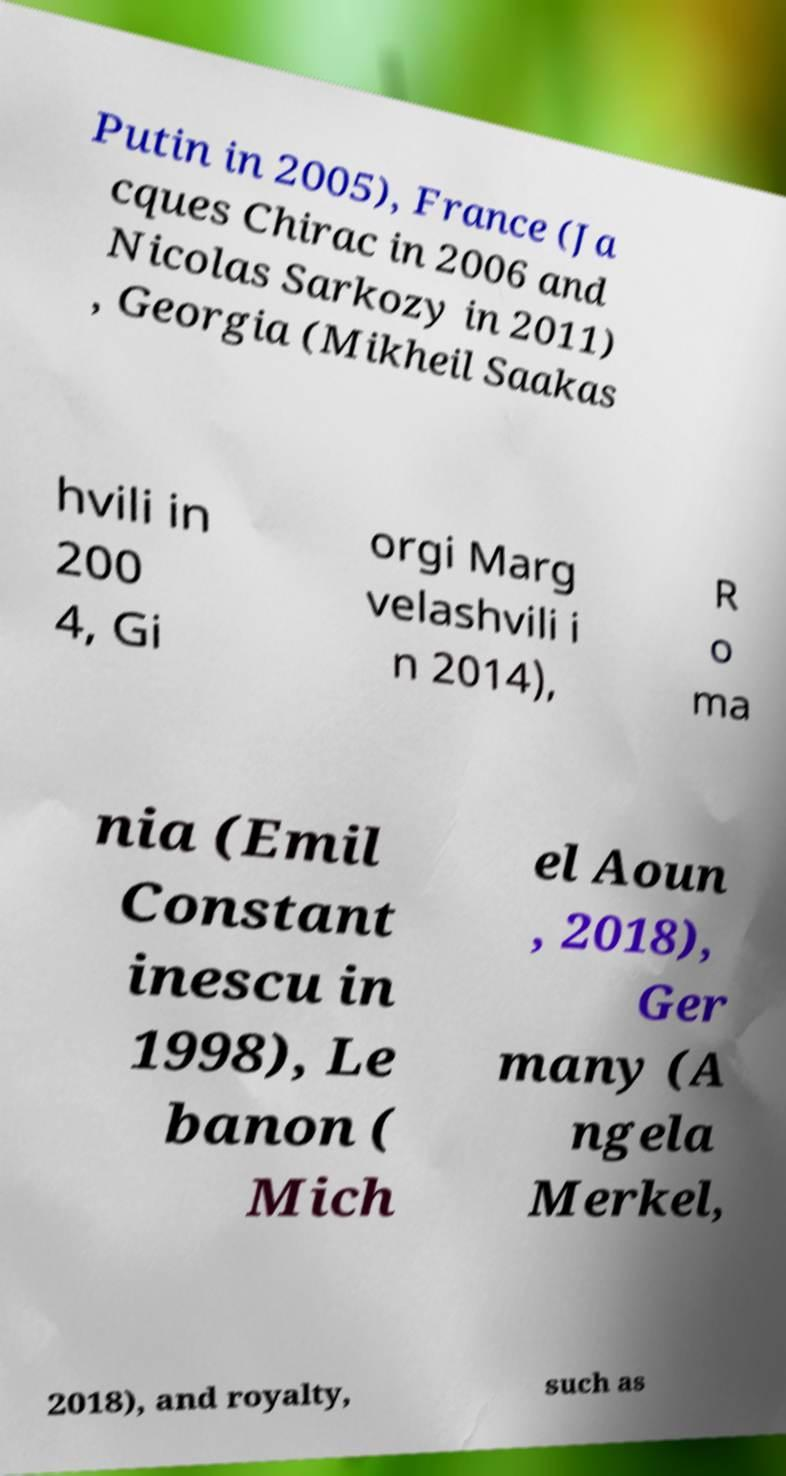Could you extract and type out the text from this image? Putin in 2005), France (Ja cques Chirac in 2006 and Nicolas Sarkozy in 2011) , Georgia (Mikheil Saakas hvili in 200 4, Gi orgi Marg velashvili i n 2014), R o ma nia (Emil Constant inescu in 1998), Le banon ( Mich el Aoun , 2018), Ger many (A ngela Merkel, 2018), and royalty, such as 